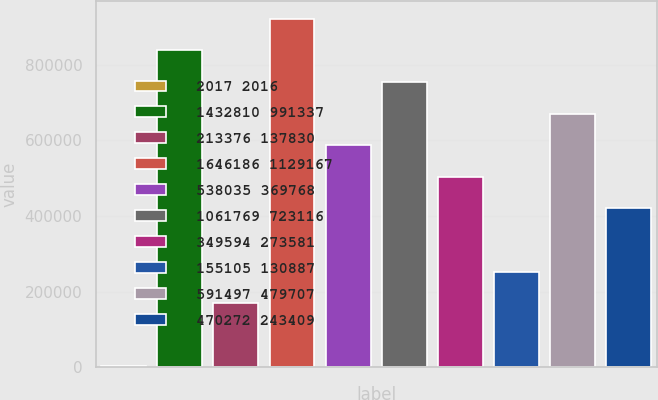Convert chart. <chart><loc_0><loc_0><loc_500><loc_500><bar_chart><fcel>2017 2016<fcel>1432810 991337<fcel>213376 137830<fcel>1646186 1129167<fcel>538035 369768<fcel>1061769 723116<fcel>349594 273581<fcel>155105 130887<fcel>591497 479707<fcel>470272 243409<nl><fcel>2015<fcel>837591<fcel>169130<fcel>921149<fcel>586918<fcel>754033<fcel>503361<fcel>252688<fcel>670476<fcel>419803<nl></chart> 